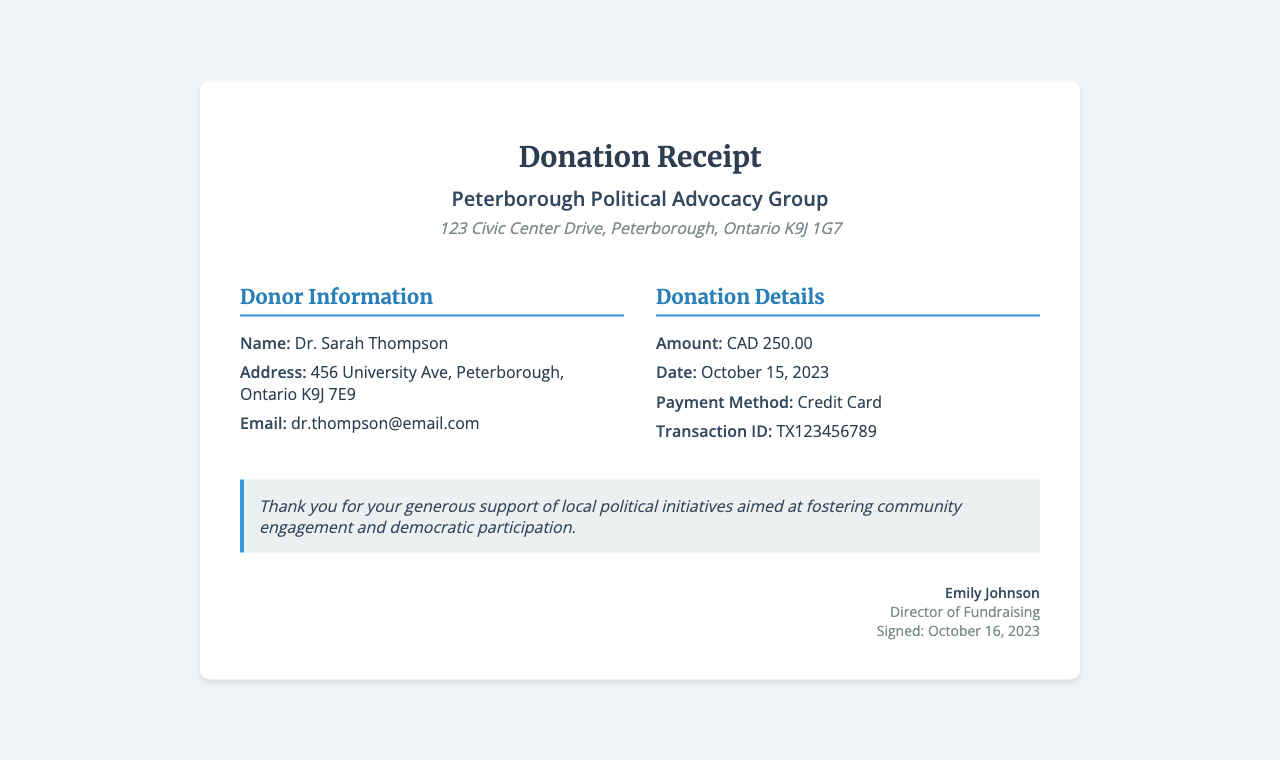What is the donor's name? The donor's name is listed in the Donor Information section of the document.
Answer: Dr. Sarah Thompson What is the donation amount? The donation amount is specifically mentioned in the Donation Details section.
Answer: CAD 250.00 What is the date of the donation? The date of the donation is stated in the Donation Details section.
Answer: October 15, 2023 What is the payment method used? The payment method is provided in the Donation Details section.
Answer: Credit Card Who is the director of fundraising? The name of the director is included in the signature section at the end of the document.
Answer: Emily Johnson What is the transaction ID? The transaction ID is found in the Donation Details section.
Answer: TX123456789 What is the organization's address? The address of the organization is listed in the header of the document.
Answer: 123 Civic Center Drive, Peterborough, Ontario K9J 1G7 What message is included in the receipt? The message is a note of appreciation supporting local political initiatives, found in the message section.
Answer: Thank you for your generous support of local political initiatives aimed at fostering community engagement and democratic participation What type of document is this? The document's title indicates it is a receipt.
Answer: Donation Receipt 